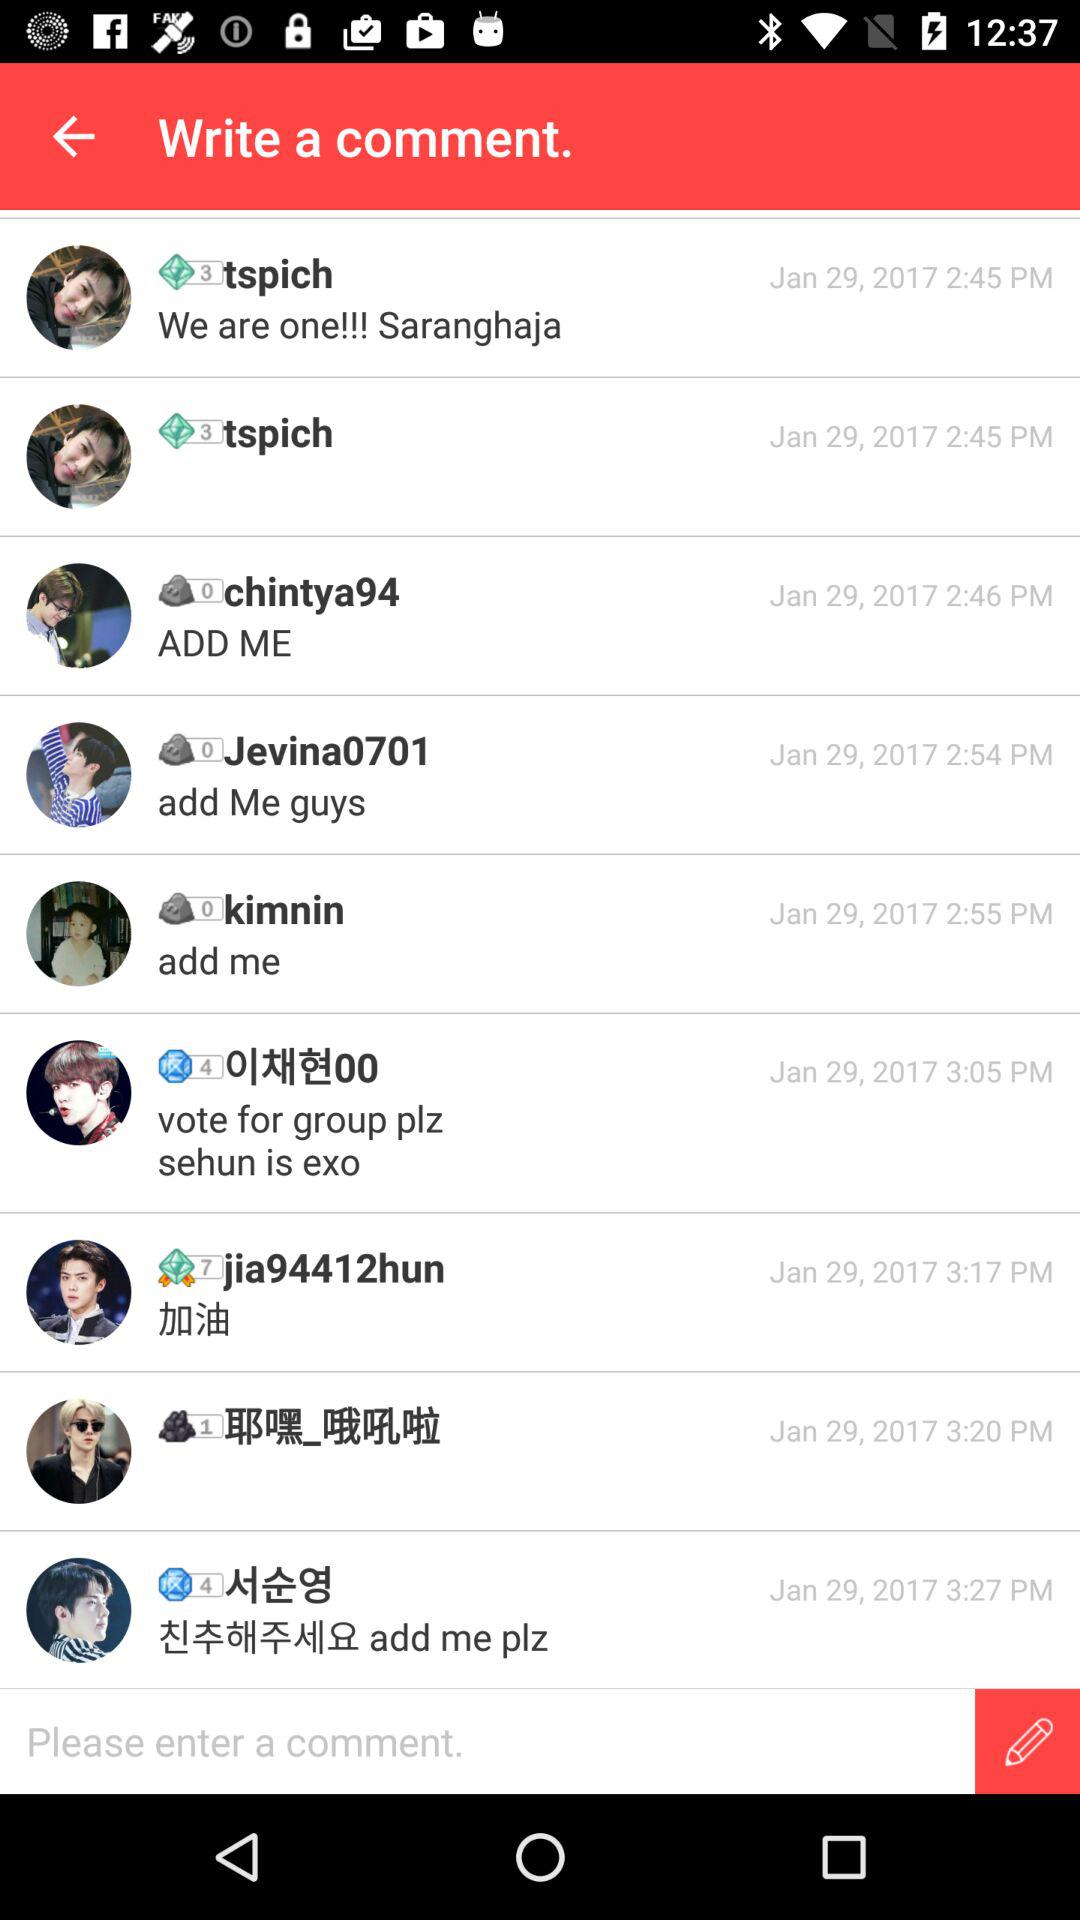What was the comment updated by "chintya94"? The comment is "ADDME". 